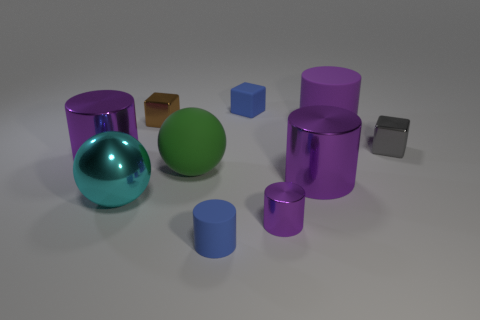How many purple cylinders must be subtracted to get 2 purple cylinders? 2 Subtract all green spheres. How many purple cylinders are left? 4 Subtract all tiny blue matte cylinders. How many cylinders are left? 4 Subtract 2 cylinders. How many cylinders are left? 3 Subtract all blue cylinders. How many cylinders are left? 4 Subtract all yellow cylinders. Subtract all yellow cubes. How many cylinders are left? 5 Subtract all spheres. How many objects are left? 8 Add 3 big balls. How many big balls exist? 5 Subtract 0 cyan cylinders. How many objects are left? 10 Subtract all big rubber balls. Subtract all small gray shiny blocks. How many objects are left? 8 